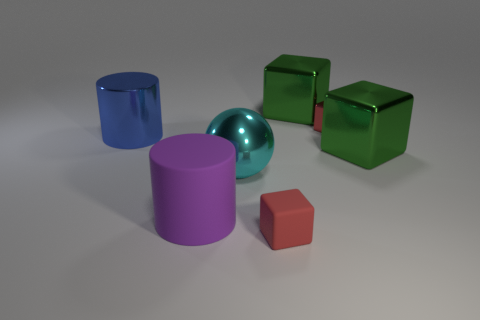Subtract all green cubes. How many were subtracted if there are1green cubes left? 1 Subtract all cylinders. How many objects are left? 5 Subtract 1 balls. How many balls are left? 0 Subtract all yellow cubes. Subtract all cyan spheres. How many cubes are left? 4 Subtract all gray cylinders. How many green blocks are left? 2 Subtract all small red metallic balls. Subtract all big cubes. How many objects are left? 5 Add 6 small red metal blocks. How many small red metal blocks are left? 7 Add 3 blue cylinders. How many blue cylinders exist? 4 Add 1 green things. How many objects exist? 8 Subtract all blue cylinders. How many cylinders are left? 1 